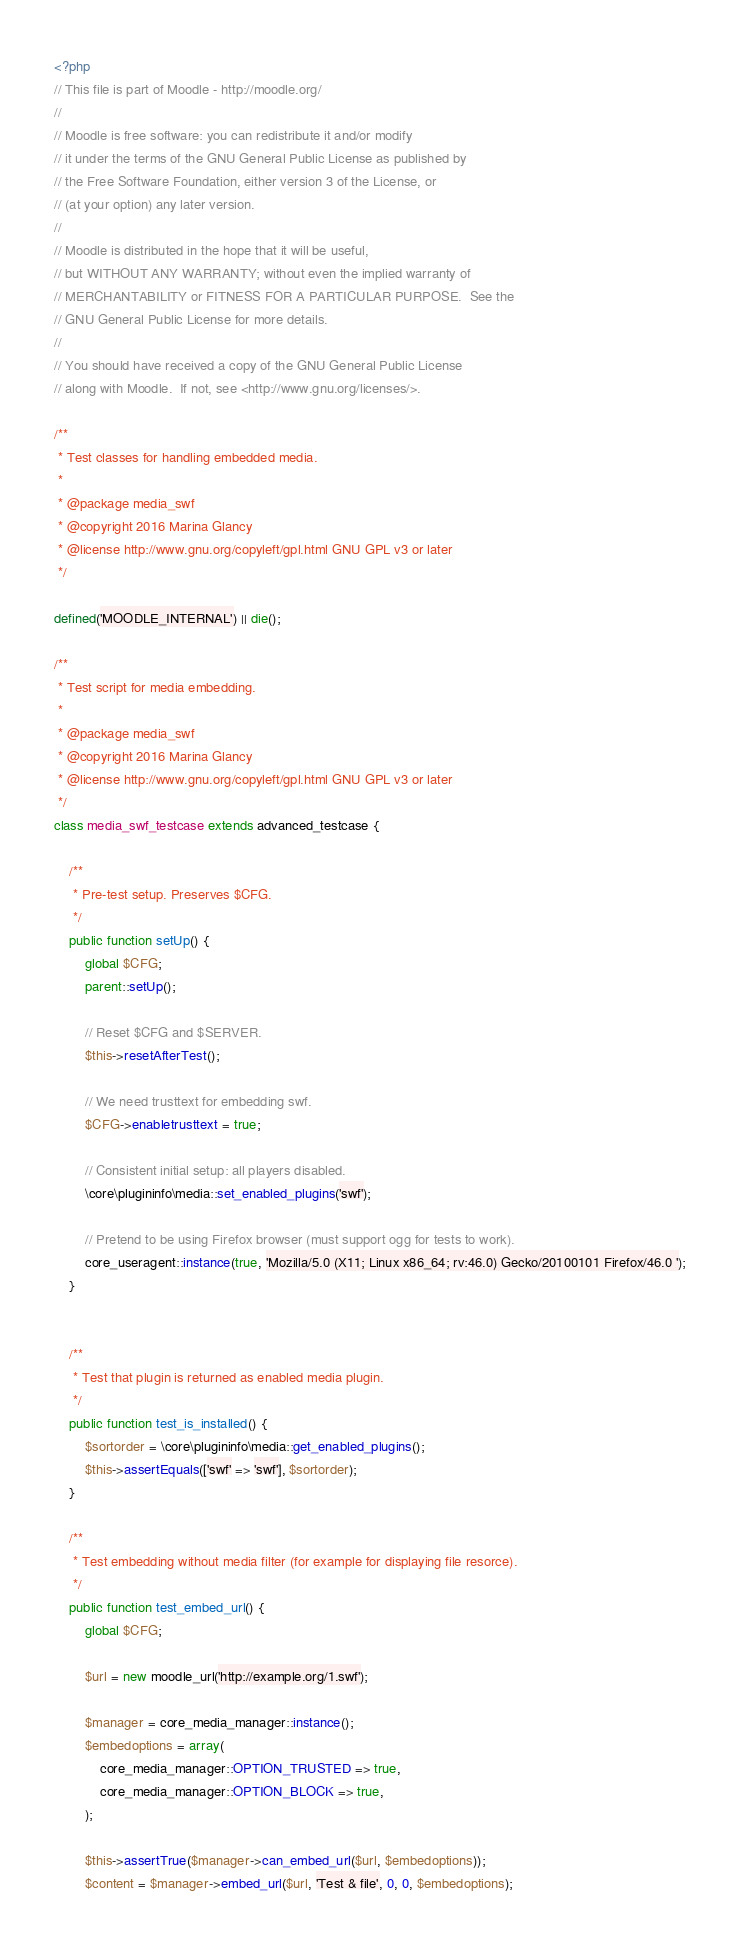Convert code to text. <code><loc_0><loc_0><loc_500><loc_500><_PHP_><?php
// This file is part of Moodle - http://moodle.org/
//
// Moodle is free software: you can redistribute it and/or modify
// it under the terms of the GNU General Public License as published by
// the Free Software Foundation, either version 3 of the License, or
// (at your option) any later version.
//
// Moodle is distributed in the hope that it will be useful,
// but WITHOUT ANY WARRANTY; without even the implied warranty of
// MERCHANTABILITY or FITNESS FOR A PARTICULAR PURPOSE.  See the
// GNU General Public License for more details.
//
// You should have received a copy of the GNU General Public License
// along with Moodle.  If not, see <http://www.gnu.org/licenses/>.

/**
 * Test classes for handling embedded media.
 *
 * @package media_swf
 * @copyright 2016 Marina Glancy
 * @license http://www.gnu.org/copyleft/gpl.html GNU GPL v3 or later
 */

defined('MOODLE_INTERNAL') || die();

/**
 * Test script for media embedding.
 *
 * @package media_swf
 * @copyright 2016 Marina Glancy
 * @license http://www.gnu.org/copyleft/gpl.html GNU GPL v3 or later
 */
class media_swf_testcase extends advanced_testcase {

    /**
     * Pre-test setup. Preserves $CFG.
     */
    public function setUp() {
        global $CFG;
        parent::setUp();

        // Reset $CFG and $SERVER.
        $this->resetAfterTest();

        // We need trusttext for embedding swf.
        $CFG->enabletrusttext = true;

        // Consistent initial setup: all players disabled.
        \core\plugininfo\media::set_enabled_plugins('swf');

        // Pretend to be using Firefox browser (must support ogg for tests to work).
        core_useragent::instance(true, 'Mozilla/5.0 (X11; Linux x86_64; rv:46.0) Gecko/20100101 Firefox/46.0 ');
    }


    /**
     * Test that plugin is returned as enabled media plugin.
     */
    public function test_is_installed() {
        $sortorder = \core\plugininfo\media::get_enabled_plugins();
        $this->assertEquals(['swf' => 'swf'], $sortorder);
    }

    /**
     * Test embedding without media filter (for example for displaying file resorce).
     */
    public function test_embed_url() {
        global $CFG;

        $url = new moodle_url('http://example.org/1.swf');

        $manager = core_media_manager::instance();
        $embedoptions = array(
            core_media_manager::OPTION_TRUSTED => true,
            core_media_manager::OPTION_BLOCK => true,
        );

        $this->assertTrue($manager->can_embed_url($url, $embedoptions));
        $content = $manager->embed_url($url, 'Test & file', 0, 0, $embedoptions);
</code> 